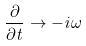<formula> <loc_0><loc_0><loc_500><loc_500>\frac { \partial } { \partial t } \rightarrow - i \omega</formula> 